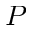Convert formula to latex. <formula><loc_0><loc_0><loc_500><loc_500>P</formula> 